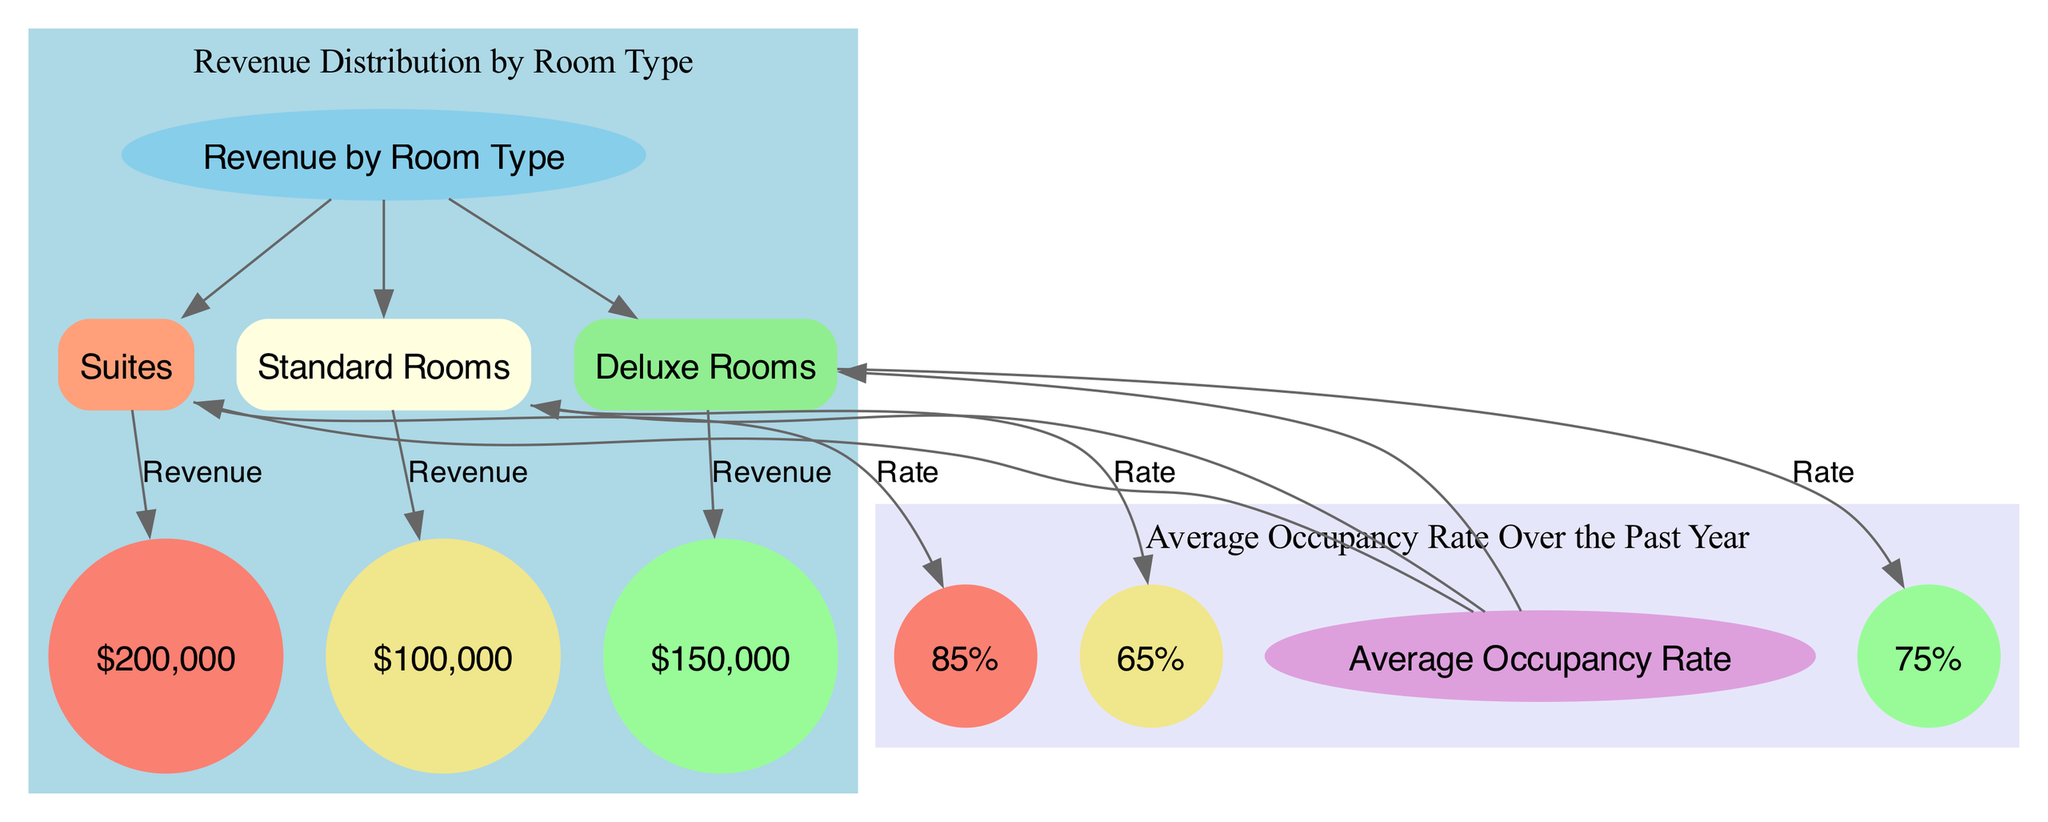What is the total revenue from Suites? The node representing Suites shows that the revenue amount is $200,000, indicating the total revenue generated from this room type.
Answer: $200,000 What is the average occupancy rate for Deluxe Rooms? The occupancy rate specifically labeled for Deluxe Rooms is represented as 75%, indicating what percentage of this room type was occupied on average.
Answer: 75% Which room type has the highest occupancy rate? By comparing the nodes representing the occupancy rates for Suites (85%), Deluxe Rooms (75%), and Standard Rooms (65%), Suites has the highest percentage, therefore indicating this room type is most frequently occupied.
Answer: Suites How many room types are represented in the diagram? The diagram includes three distinct room types: Suites, Deluxe Rooms, and Standard Rooms. Counting these nodes gives a total of three different room types.
Answer: 3 What is the relationship between Revenue and Standard Rooms? The diagram shows an edge connecting Standard Rooms to Revenue, meaning there is a direct link between the room type and its corresponding revenue amount, which is shown as $100,000.
Answer: Revenue Which room type generates the least revenue? By examining the revenue figures attached to each room type, Standard Rooms generate the least revenue at $100,000.
Answer: Standard Rooms What is the total revenue generated by all room types? To find the total revenue, we sum the individual revenues: $200,000 (Suites) + $150,000 (Deluxe Rooms) + $100,000 (Standard Rooms), resulting in $450,000 total revenue.
Answer: $450,000 What is the occupancy rate of Standard Rooms? The occupancy rate specifically for Standard Rooms is illustrated as 65%, showing the average occupancy for this category of room.
Answer: 65% Which room type has a revenue of $150,000? The node represents Deluxe Rooms shows the revenue amount of $150,000, indicating that this specific room type generates this total revenue.
Answer: Deluxe Rooms 